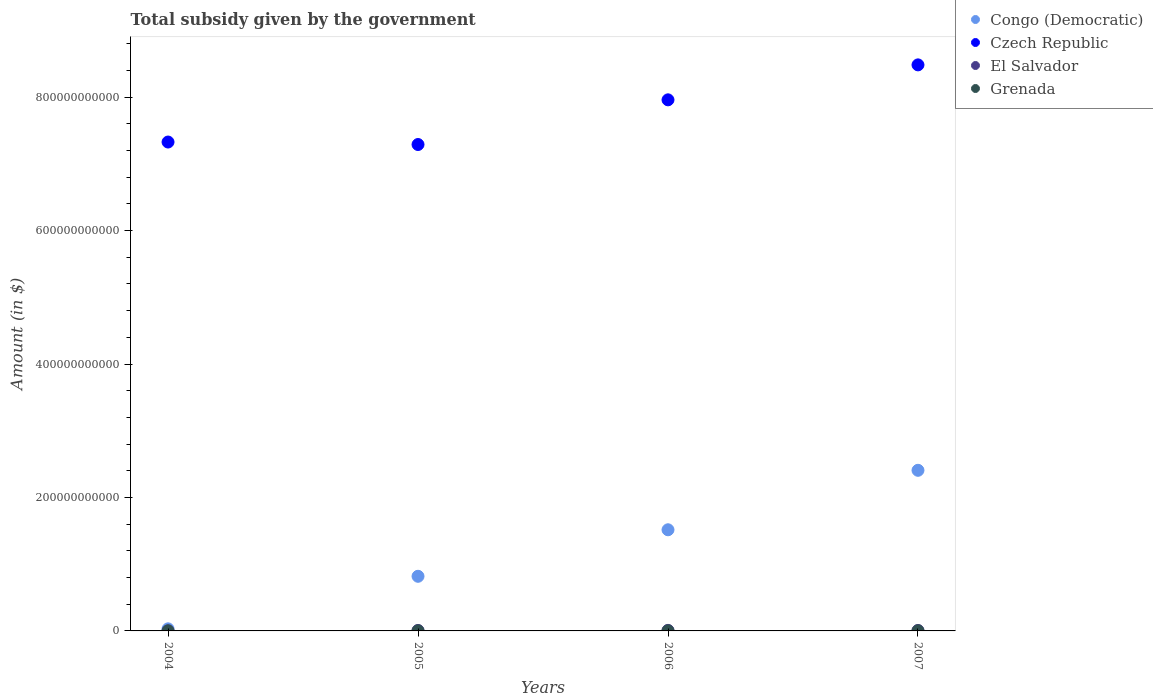How many different coloured dotlines are there?
Keep it short and to the point. 4. What is the total revenue collected by the government in Grenada in 2004?
Ensure brevity in your answer.  5.53e+07. Across all years, what is the maximum total revenue collected by the government in Grenada?
Give a very brief answer. 7.55e+07. Across all years, what is the minimum total revenue collected by the government in Grenada?
Provide a succinct answer. 5.46e+07. What is the total total revenue collected by the government in El Salvador in the graph?
Ensure brevity in your answer.  2.44e+09. What is the difference between the total revenue collected by the government in Congo (Democratic) in 2005 and that in 2006?
Your answer should be compact. -6.97e+1. What is the difference between the total revenue collected by the government in Grenada in 2006 and the total revenue collected by the government in Congo (Democratic) in 2005?
Your answer should be very brief. -8.18e+1. What is the average total revenue collected by the government in Grenada per year?
Ensure brevity in your answer.  6.34e+07. In the year 2005, what is the difference between the total revenue collected by the government in Congo (Democratic) and total revenue collected by the government in Czech Republic?
Provide a short and direct response. -6.47e+11. What is the ratio of the total revenue collected by the government in El Salvador in 2004 to that in 2005?
Provide a short and direct response. 0.17. Is the difference between the total revenue collected by the government in Congo (Democratic) in 2004 and 2006 greater than the difference between the total revenue collected by the government in Czech Republic in 2004 and 2006?
Keep it short and to the point. No. What is the difference between the highest and the second highest total revenue collected by the government in Congo (Democratic)?
Offer a very short reply. 8.91e+1. What is the difference between the highest and the lowest total revenue collected by the government in Czech Republic?
Your answer should be compact. 1.19e+11. In how many years, is the total revenue collected by the government in Czech Republic greater than the average total revenue collected by the government in Czech Republic taken over all years?
Keep it short and to the point. 2. Is it the case that in every year, the sum of the total revenue collected by the government in El Salvador and total revenue collected by the government in Grenada  is greater than the total revenue collected by the government in Czech Republic?
Your answer should be compact. No. Is the total revenue collected by the government in El Salvador strictly greater than the total revenue collected by the government in Congo (Democratic) over the years?
Ensure brevity in your answer.  No. What is the difference between two consecutive major ticks on the Y-axis?
Offer a very short reply. 2.00e+11. Does the graph contain grids?
Provide a succinct answer. No. Where does the legend appear in the graph?
Give a very brief answer. Top right. How many legend labels are there?
Make the answer very short. 4. What is the title of the graph?
Provide a succinct answer. Total subsidy given by the government. What is the label or title of the X-axis?
Ensure brevity in your answer.  Years. What is the label or title of the Y-axis?
Your answer should be compact. Amount (in $). What is the Amount (in $) of Congo (Democratic) in 2004?
Give a very brief answer. 3.12e+09. What is the Amount (in $) in Czech Republic in 2004?
Keep it short and to the point. 7.33e+11. What is the Amount (in $) in El Salvador in 2004?
Provide a short and direct response. 1.26e+08. What is the Amount (in $) in Grenada in 2004?
Your answer should be compact. 5.53e+07. What is the Amount (in $) in Congo (Democratic) in 2005?
Ensure brevity in your answer.  8.19e+1. What is the Amount (in $) of Czech Republic in 2005?
Provide a succinct answer. 7.29e+11. What is the Amount (in $) of El Salvador in 2005?
Your answer should be compact. 7.40e+08. What is the Amount (in $) of Grenada in 2005?
Offer a terse response. 5.46e+07. What is the Amount (in $) of Congo (Democratic) in 2006?
Your answer should be compact. 1.52e+11. What is the Amount (in $) in Czech Republic in 2006?
Your response must be concise. 7.96e+11. What is the Amount (in $) of El Salvador in 2006?
Make the answer very short. 8.40e+08. What is the Amount (in $) of Grenada in 2006?
Your answer should be very brief. 6.83e+07. What is the Amount (in $) of Congo (Democratic) in 2007?
Offer a very short reply. 2.41e+11. What is the Amount (in $) of Czech Republic in 2007?
Offer a very short reply. 8.48e+11. What is the Amount (in $) in El Salvador in 2007?
Provide a succinct answer. 7.31e+08. What is the Amount (in $) in Grenada in 2007?
Your response must be concise. 7.55e+07. Across all years, what is the maximum Amount (in $) in Congo (Democratic)?
Provide a succinct answer. 2.41e+11. Across all years, what is the maximum Amount (in $) of Czech Republic?
Make the answer very short. 8.48e+11. Across all years, what is the maximum Amount (in $) of El Salvador?
Your answer should be very brief. 8.40e+08. Across all years, what is the maximum Amount (in $) in Grenada?
Your answer should be compact. 7.55e+07. Across all years, what is the minimum Amount (in $) of Congo (Democratic)?
Offer a very short reply. 3.12e+09. Across all years, what is the minimum Amount (in $) of Czech Republic?
Ensure brevity in your answer.  7.29e+11. Across all years, what is the minimum Amount (in $) in El Salvador?
Your response must be concise. 1.26e+08. Across all years, what is the minimum Amount (in $) in Grenada?
Your answer should be compact. 5.46e+07. What is the total Amount (in $) of Congo (Democratic) in the graph?
Give a very brief answer. 4.77e+11. What is the total Amount (in $) in Czech Republic in the graph?
Offer a very short reply. 3.11e+12. What is the total Amount (in $) of El Salvador in the graph?
Provide a short and direct response. 2.44e+09. What is the total Amount (in $) of Grenada in the graph?
Offer a terse response. 2.54e+08. What is the difference between the Amount (in $) in Congo (Democratic) in 2004 and that in 2005?
Offer a terse response. -7.88e+1. What is the difference between the Amount (in $) in Czech Republic in 2004 and that in 2005?
Give a very brief answer. 3.72e+09. What is the difference between the Amount (in $) of El Salvador in 2004 and that in 2005?
Make the answer very short. -6.14e+08. What is the difference between the Amount (in $) in Grenada in 2004 and that in 2005?
Keep it short and to the point. 7.00e+05. What is the difference between the Amount (in $) in Congo (Democratic) in 2004 and that in 2006?
Provide a succinct answer. -1.48e+11. What is the difference between the Amount (in $) of Czech Republic in 2004 and that in 2006?
Provide a short and direct response. -6.32e+1. What is the difference between the Amount (in $) in El Salvador in 2004 and that in 2006?
Give a very brief answer. -7.13e+08. What is the difference between the Amount (in $) in Grenada in 2004 and that in 2006?
Make the answer very short. -1.30e+07. What is the difference between the Amount (in $) in Congo (Democratic) in 2004 and that in 2007?
Your answer should be compact. -2.38e+11. What is the difference between the Amount (in $) in Czech Republic in 2004 and that in 2007?
Offer a terse response. -1.16e+11. What is the difference between the Amount (in $) in El Salvador in 2004 and that in 2007?
Ensure brevity in your answer.  -6.05e+08. What is the difference between the Amount (in $) in Grenada in 2004 and that in 2007?
Give a very brief answer. -2.02e+07. What is the difference between the Amount (in $) in Congo (Democratic) in 2005 and that in 2006?
Provide a short and direct response. -6.97e+1. What is the difference between the Amount (in $) in Czech Republic in 2005 and that in 2006?
Your answer should be very brief. -6.70e+1. What is the difference between the Amount (in $) of El Salvador in 2005 and that in 2006?
Ensure brevity in your answer.  -9.95e+07. What is the difference between the Amount (in $) in Grenada in 2005 and that in 2006?
Provide a succinct answer. -1.37e+07. What is the difference between the Amount (in $) of Congo (Democratic) in 2005 and that in 2007?
Give a very brief answer. -1.59e+11. What is the difference between the Amount (in $) in Czech Republic in 2005 and that in 2007?
Keep it short and to the point. -1.19e+11. What is the difference between the Amount (in $) in El Salvador in 2005 and that in 2007?
Your answer should be compact. 8.80e+06. What is the difference between the Amount (in $) in Grenada in 2005 and that in 2007?
Provide a short and direct response. -2.09e+07. What is the difference between the Amount (in $) of Congo (Democratic) in 2006 and that in 2007?
Your response must be concise. -8.91e+1. What is the difference between the Amount (in $) of Czech Republic in 2006 and that in 2007?
Offer a very short reply. -5.24e+1. What is the difference between the Amount (in $) of El Salvador in 2006 and that in 2007?
Give a very brief answer. 1.08e+08. What is the difference between the Amount (in $) in Grenada in 2006 and that in 2007?
Give a very brief answer. -7.20e+06. What is the difference between the Amount (in $) of Congo (Democratic) in 2004 and the Amount (in $) of Czech Republic in 2005?
Provide a succinct answer. -7.26e+11. What is the difference between the Amount (in $) of Congo (Democratic) in 2004 and the Amount (in $) of El Salvador in 2005?
Ensure brevity in your answer.  2.38e+09. What is the difference between the Amount (in $) in Congo (Democratic) in 2004 and the Amount (in $) in Grenada in 2005?
Your answer should be compact. 3.07e+09. What is the difference between the Amount (in $) of Czech Republic in 2004 and the Amount (in $) of El Salvador in 2005?
Offer a very short reply. 7.32e+11. What is the difference between the Amount (in $) of Czech Republic in 2004 and the Amount (in $) of Grenada in 2005?
Offer a terse response. 7.33e+11. What is the difference between the Amount (in $) of El Salvador in 2004 and the Amount (in $) of Grenada in 2005?
Provide a short and direct response. 7.19e+07. What is the difference between the Amount (in $) of Congo (Democratic) in 2004 and the Amount (in $) of Czech Republic in 2006?
Ensure brevity in your answer.  -7.93e+11. What is the difference between the Amount (in $) of Congo (Democratic) in 2004 and the Amount (in $) of El Salvador in 2006?
Keep it short and to the point. 2.28e+09. What is the difference between the Amount (in $) in Congo (Democratic) in 2004 and the Amount (in $) in Grenada in 2006?
Ensure brevity in your answer.  3.05e+09. What is the difference between the Amount (in $) of Czech Republic in 2004 and the Amount (in $) of El Salvador in 2006?
Make the answer very short. 7.32e+11. What is the difference between the Amount (in $) of Czech Republic in 2004 and the Amount (in $) of Grenada in 2006?
Keep it short and to the point. 7.33e+11. What is the difference between the Amount (in $) in El Salvador in 2004 and the Amount (in $) in Grenada in 2006?
Give a very brief answer. 5.82e+07. What is the difference between the Amount (in $) in Congo (Democratic) in 2004 and the Amount (in $) in Czech Republic in 2007?
Your response must be concise. -8.45e+11. What is the difference between the Amount (in $) in Congo (Democratic) in 2004 and the Amount (in $) in El Salvador in 2007?
Provide a succinct answer. 2.39e+09. What is the difference between the Amount (in $) of Congo (Democratic) in 2004 and the Amount (in $) of Grenada in 2007?
Give a very brief answer. 3.05e+09. What is the difference between the Amount (in $) in Czech Republic in 2004 and the Amount (in $) in El Salvador in 2007?
Keep it short and to the point. 7.32e+11. What is the difference between the Amount (in $) of Czech Republic in 2004 and the Amount (in $) of Grenada in 2007?
Make the answer very short. 7.33e+11. What is the difference between the Amount (in $) of El Salvador in 2004 and the Amount (in $) of Grenada in 2007?
Your response must be concise. 5.10e+07. What is the difference between the Amount (in $) of Congo (Democratic) in 2005 and the Amount (in $) of Czech Republic in 2006?
Keep it short and to the point. -7.14e+11. What is the difference between the Amount (in $) of Congo (Democratic) in 2005 and the Amount (in $) of El Salvador in 2006?
Give a very brief answer. 8.11e+1. What is the difference between the Amount (in $) in Congo (Democratic) in 2005 and the Amount (in $) in Grenada in 2006?
Your answer should be very brief. 8.18e+1. What is the difference between the Amount (in $) in Czech Republic in 2005 and the Amount (in $) in El Salvador in 2006?
Provide a short and direct response. 7.28e+11. What is the difference between the Amount (in $) of Czech Republic in 2005 and the Amount (in $) of Grenada in 2006?
Keep it short and to the point. 7.29e+11. What is the difference between the Amount (in $) of El Salvador in 2005 and the Amount (in $) of Grenada in 2006?
Offer a terse response. 6.72e+08. What is the difference between the Amount (in $) in Congo (Democratic) in 2005 and the Amount (in $) in Czech Republic in 2007?
Make the answer very short. -7.67e+11. What is the difference between the Amount (in $) of Congo (Democratic) in 2005 and the Amount (in $) of El Salvador in 2007?
Make the answer very short. 8.12e+1. What is the difference between the Amount (in $) of Congo (Democratic) in 2005 and the Amount (in $) of Grenada in 2007?
Provide a succinct answer. 8.18e+1. What is the difference between the Amount (in $) in Czech Republic in 2005 and the Amount (in $) in El Salvador in 2007?
Give a very brief answer. 7.28e+11. What is the difference between the Amount (in $) of Czech Republic in 2005 and the Amount (in $) of Grenada in 2007?
Ensure brevity in your answer.  7.29e+11. What is the difference between the Amount (in $) in El Salvador in 2005 and the Amount (in $) in Grenada in 2007?
Provide a succinct answer. 6.64e+08. What is the difference between the Amount (in $) in Congo (Democratic) in 2006 and the Amount (in $) in Czech Republic in 2007?
Make the answer very short. -6.97e+11. What is the difference between the Amount (in $) of Congo (Democratic) in 2006 and the Amount (in $) of El Salvador in 2007?
Offer a very short reply. 1.51e+11. What is the difference between the Amount (in $) of Congo (Democratic) in 2006 and the Amount (in $) of Grenada in 2007?
Keep it short and to the point. 1.52e+11. What is the difference between the Amount (in $) in Czech Republic in 2006 and the Amount (in $) in El Salvador in 2007?
Your answer should be very brief. 7.95e+11. What is the difference between the Amount (in $) of Czech Republic in 2006 and the Amount (in $) of Grenada in 2007?
Your answer should be very brief. 7.96e+11. What is the difference between the Amount (in $) of El Salvador in 2006 and the Amount (in $) of Grenada in 2007?
Ensure brevity in your answer.  7.64e+08. What is the average Amount (in $) in Congo (Democratic) per year?
Your response must be concise. 1.19e+11. What is the average Amount (in $) in Czech Republic per year?
Provide a succinct answer. 7.77e+11. What is the average Amount (in $) in El Salvador per year?
Provide a short and direct response. 6.09e+08. What is the average Amount (in $) in Grenada per year?
Make the answer very short. 6.34e+07. In the year 2004, what is the difference between the Amount (in $) of Congo (Democratic) and Amount (in $) of Czech Republic?
Provide a succinct answer. -7.30e+11. In the year 2004, what is the difference between the Amount (in $) of Congo (Democratic) and Amount (in $) of El Salvador?
Your answer should be very brief. 3.00e+09. In the year 2004, what is the difference between the Amount (in $) of Congo (Democratic) and Amount (in $) of Grenada?
Make the answer very short. 3.07e+09. In the year 2004, what is the difference between the Amount (in $) of Czech Republic and Amount (in $) of El Salvador?
Keep it short and to the point. 7.33e+11. In the year 2004, what is the difference between the Amount (in $) in Czech Republic and Amount (in $) in Grenada?
Your response must be concise. 7.33e+11. In the year 2004, what is the difference between the Amount (in $) of El Salvador and Amount (in $) of Grenada?
Your answer should be very brief. 7.12e+07. In the year 2005, what is the difference between the Amount (in $) in Congo (Democratic) and Amount (in $) in Czech Republic?
Offer a terse response. -6.47e+11. In the year 2005, what is the difference between the Amount (in $) in Congo (Democratic) and Amount (in $) in El Salvador?
Make the answer very short. 8.12e+1. In the year 2005, what is the difference between the Amount (in $) of Congo (Democratic) and Amount (in $) of Grenada?
Give a very brief answer. 8.18e+1. In the year 2005, what is the difference between the Amount (in $) of Czech Republic and Amount (in $) of El Salvador?
Provide a succinct answer. 7.28e+11. In the year 2005, what is the difference between the Amount (in $) in Czech Republic and Amount (in $) in Grenada?
Your answer should be very brief. 7.29e+11. In the year 2005, what is the difference between the Amount (in $) in El Salvador and Amount (in $) in Grenada?
Offer a very short reply. 6.85e+08. In the year 2006, what is the difference between the Amount (in $) of Congo (Democratic) and Amount (in $) of Czech Republic?
Offer a terse response. -6.44e+11. In the year 2006, what is the difference between the Amount (in $) in Congo (Democratic) and Amount (in $) in El Salvador?
Provide a succinct answer. 1.51e+11. In the year 2006, what is the difference between the Amount (in $) of Congo (Democratic) and Amount (in $) of Grenada?
Provide a succinct answer. 1.52e+11. In the year 2006, what is the difference between the Amount (in $) in Czech Republic and Amount (in $) in El Salvador?
Give a very brief answer. 7.95e+11. In the year 2006, what is the difference between the Amount (in $) of Czech Republic and Amount (in $) of Grenada?
Your response must be concise. 7.96e+11. In the year 2006, what is the difference between the Amount (in $) of El Salvador and Amount (in $) of Grenada?
Make the answer very short. 7.71e+08. In the year 2007, what is the difference between the Amount (in $) in Congo (Democratic) and Amount (in $) in Czech Republic?
Offer a terse response. -6.08e+11. In the year 2007, what is the difference between the Amount (in $) in Congo (Democratic) and Amount (in $) in El Salvador?
Your answer should be very brief. 2.40e+11. In the year 2007, what is the difference between the Amount (in $) of Congo (Democratic) and Amount (in $) of Grenada?
Keep it short and to the point. 2.41e+11. In the year 2007, what is the difference between the Amount (in $) of Czech Republic and Amount (in $) of El Salvador?
Keep it short and to the point. 8.48e+11. In the year 2007, what is the difference between the Amount (in $) in Czech Republic and Amount (in $) in Grenada?
Your answer should be very brief. 8.48e+11. In the year 2007, what is the difference between the Amount (in $) of El Salvador and Amount (in $) of Grenada?
Offer a terse response. 6.56e+08. What is the ratio of the Amount (in $) of Congo (Democratic) in 2004 to that in 2005?
Provide a succinct answer. 0.04. What is the ratio of the Amount (in $) in El Salvador in 2004 to that in 2005?
Provide a succinct answer. 0.17. What is the ratio of the Amount (in $) of Grenada in 2004 to that in 2005?
Your response must be concise. 1.01. What is the ratio of the Amount (in $) of Congo (Democratic) in 2004 to that in 2006?
Provide a succinct answer. 0.02. What is the ratio of the Amount (in $) in Czech Republic in 2004 to that in 2006?
Ensure brevity in your answer.  0.92. What is the ratio of the Amount (in $) in El Salvador in 2004 to that in 2006?
Provide a short and direct response. 0.15. What is the ratio of the Amount (in $) in Grenada in 2004 to that in 2006?
Provide a short and direct response. 0.81. What is the ratio of the Amount (in $) of Congo (Democratic) in 2004 to that in 2007?
Make the answer very short. 0.01. What is the ratio of the Amount (in $) in Czech Republic in 2004 to that in 2007?
Ensure brevity in your answer.  0.86. What is the ratio of the Amount (in $) in El Salvador in 2004 to that in 2007?
Your response must be concise. 0.17. What is the ratio of the Amount (in $) of Grenada in 2004 to that in 2007?
Your answer should be very brief. 0.73. What is the ratio of the Amount (in $) in Congo (Democratic) in 2005 to that in 2006?
Your answer should be very brief. 0.54. What is the ratio of the Amount (in $) of Czech Republic in 2005 to that in 2006?
Provide a short and direct response. 0.92. What is the ratio of the Amount (in $) of El Salvador in 2005 to that in 2006?
Your answer should be compact. 0.88. What is the ratio of the Amount (in $) of Grenada in 2005 to that in 2006?
Offer a very short reply. 0.8. What is the ratio of the Amount (in $) in Congo (Democratic) in 2005 to that in 2007?
Your answer should be very brief. 0.34. What is the ratio of the Amount (in $) of Czech Republic in 2005 to that in 2007?
Give a very brief answer. 0.86. What is the ratio of the Amount (in $) of El Salvador in 2005 to that in 2007?
Make the answer very short. 1.01. What is the ratio of the Amount (in $) of Grenada in 2005 to that in 2007?
Your answer should be very brief. 0.72. What is the ratio of the Amount (in $) of Congo (Democratic) in 2006 to that in 2007?
Make the answer very short. 0.63. What is the ratio of the Amount (in $) of Czech Republic in 2006 to that in 2007?
Your answer should be very brief. 0.94. What is the ratio of the Amount (in $) of El Salvador in 2006 to that in 2007?
Your response must be concise. 1.15. What is the ratio of the Amount (in $) of Grenada in 2006 to that in 2007?
Your answer should be very brief. 0.9. What is the difference between the highest and the second highest Amount (in $) in Congo (Democratic)?
Your answer should be compact. 8.91e+1. What is the difference between the highest and the second highest Amount (in $) in Czech Republic?
Offer a terse response. 5.24e+1. What is the difference between the highest and the second highest Amount (in $) of El Salvador?
Make the answer very short. 9.95e+07. What is the difference between the highest and the second highest Amount (in $) in Grenada?
Ensure brevity in your answer.  7.20e+06. What is the difference between the highest and the lowest Amount (in $) in Congo (Democratic)?
Ensure brevity in your answer.  2.38e+11. What is the difference between the highest and the lowest Amount (in $) in Czech Republic?
Your response must be concise. 1.19e+11. What is the difference between the highest and the lowest Amount (in $) of El Salvador?
Your answer should be very brief. 7.13e+08. What is the difference between the highest and the lowest Amount (in $) of Grenada?
Give a very brief answer. 2.09e+07. 